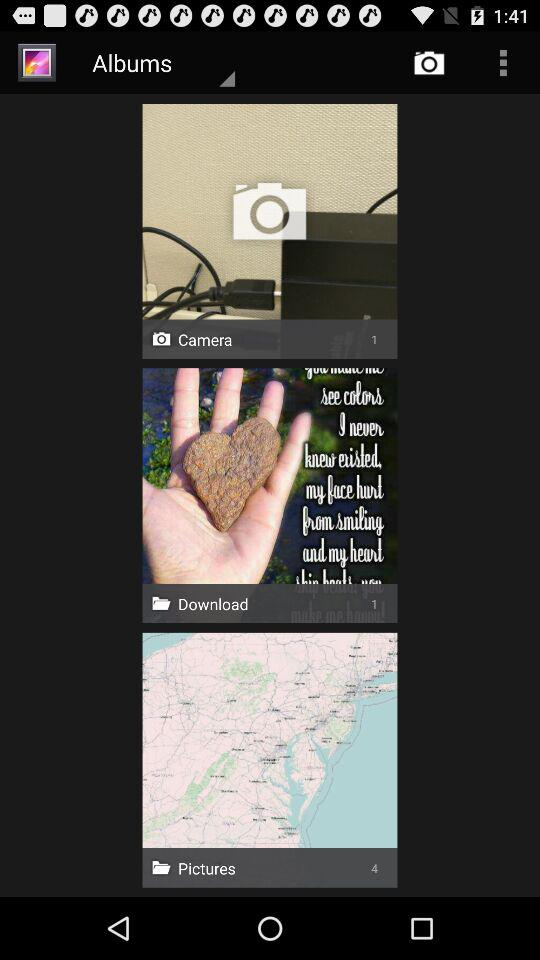How many more pictures than downloads are there?
Answer the question using a single word or phrase. 3 